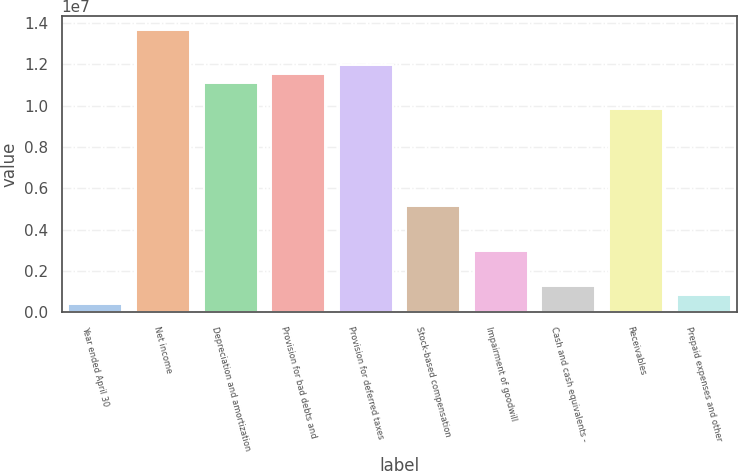Convert chart. <chart><loc_0><loc_0><loc_500><loc_500><bar_chart><fcel>Year ended April 30<fcel>Net income<fcel>Depreciation and amortization<fcel>Provision for bad debts and<fcel>Provision for deferred taxes<fcel>Stock-based compensation<fcel>Impairment of goodwill<fcel>Cash and cash equivalents -<fcel>Receivables<fcel>Prepaid expenses and other<nl><fcel>427052<fcel>1.36562e+07<fcel>1.10957e+07<fcel>1.15225e+07<fcel>1.19492e+07<fcel>5.12127e+06<fcel>2.98753e+06<fcel>1.28055e+06<fcel>9.81548e+06<fcel>853799<nl></chart> 